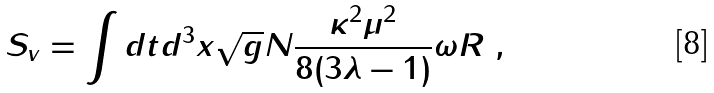<formula> <loc_0><loc_0><loc_500><loc_500>S _ { v } = \int d t d ^ { 3 } x \sqrt { g } N \frac { \kappa ^ { 2 } \mu ^ { 2 } } { 8 ( 3 \lambda - 1 ) } \omega R \ ,</formula> 